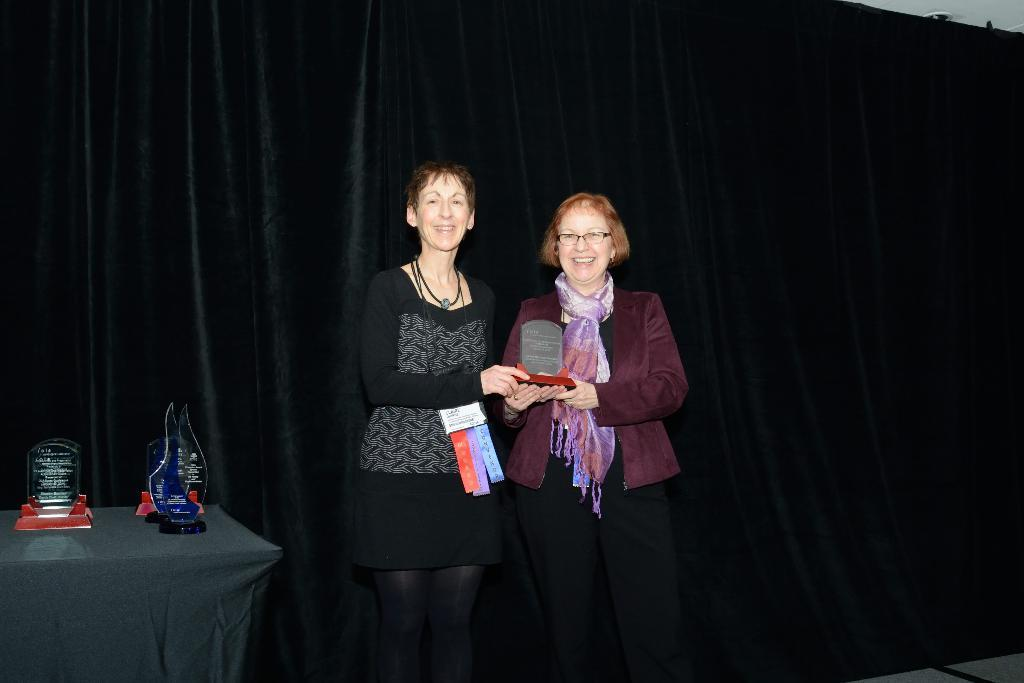How many people are in the image? There are two people in the image. What are the people doing in the image? The people are smiling in the image. What are the people holding in the image? The people are holding a crystal trophy in the image. What else can be seen related to crystal trophies in the image? There are crystal trophies on a table in the image. Can you tell me how many crows are perched on the crystal trophies in the image? There are no crows present in the image; it only features people and crystal trophies. What type of suggestion is being made by the people holding the crystal trophies in the image? There is no suggestion being made in the image; the people are simply holding the crystal trophies. 